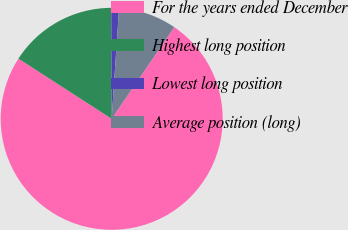<chart> <loc_0><loc_0><loc_500><loc_500><pie_chart><fcel>For the years ended December<fcel>Highest long position<fcel>Lowest long position<fcel>Average position (long)<nl><fcel>74.6%<fcel>15.82%<fcel>1.12%<fcel>8.47%<nl></chart> 